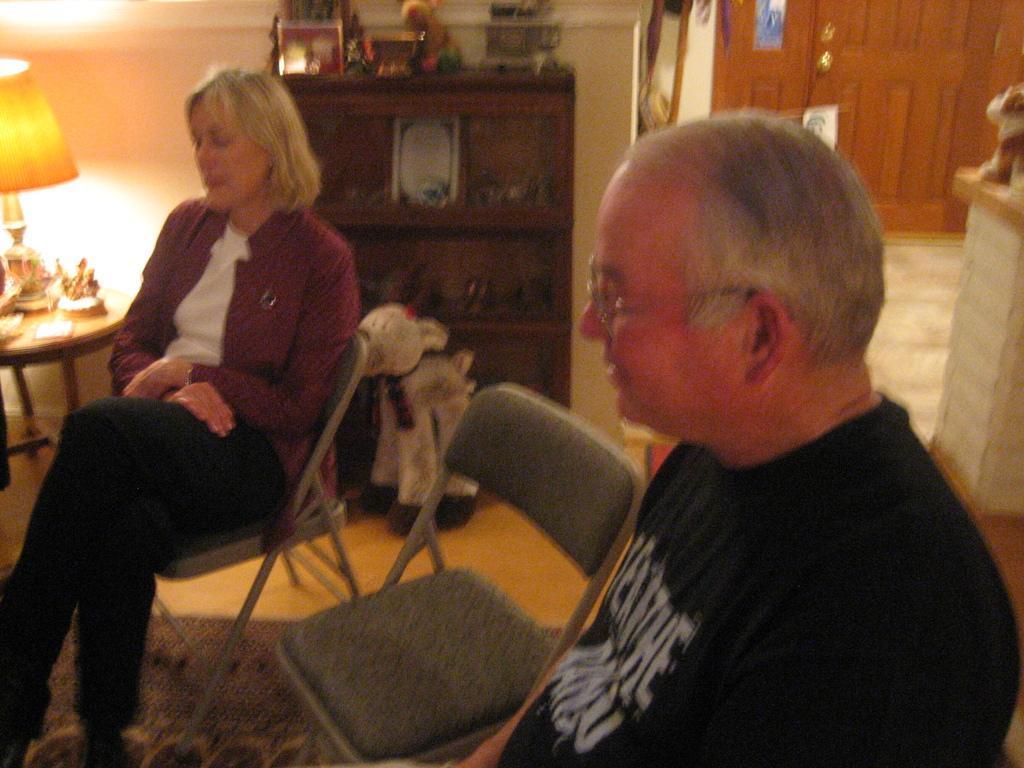Please provide a concise description of this image. In this picture we can see people are sitting on the chairs, side we can see the table on which few objects are placed along with lamp, some toys in a shelf and we can see windows, doors to the wall. 